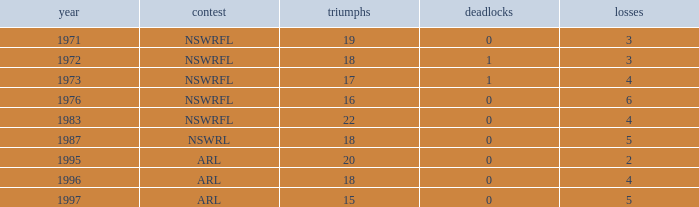What sum of Losses has Year greater than 1972, and Competition of nswrfl, and Draws 0, and Wins 16? 6.0. 